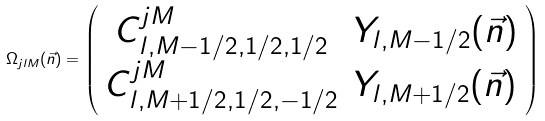<formula> <loc_0><loc_0><loc_500><loc_500>\Omega _ { j l M } ( \vec { n } ) = \left ( \begin{array} { c c } C ^ { j M } _ { l , M - 1 / 2 , 1 / 2 , 1 / 2 } & Y _ { l , M - 1 / 2 } ( \vec { n } ) \\ C ^ { j M } _ { l , M + 1 / 2 , 1 / 2 , - 1 / 2 } & Y _ { l , M + 1 / 2 } ( \vec { n } ) \end{array} \right )</formula> 